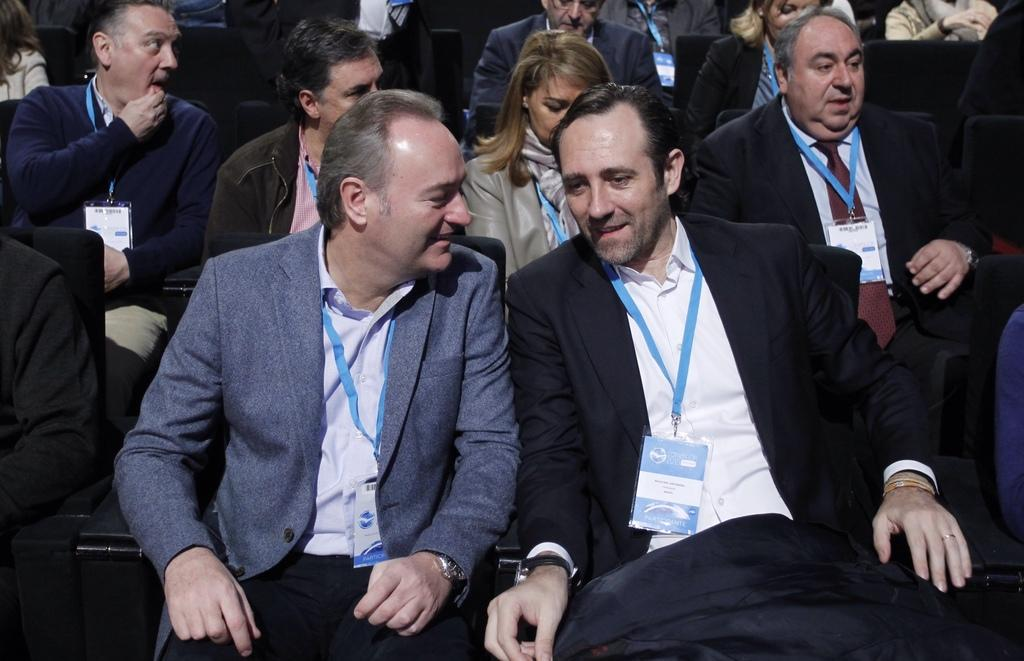What is the main subject of the image? The main subject of the image is a group of people. How can you describe the appearance of the people in the image? The people are wearing different color dresses. What objects are the people holding in the image? The people have identification cards. What are the people doing in the image? The people are sitting on chairs. Can you see any robins in the image? No, there are no robins present in the image. What type of beds are the people lying on in the image? There are no beds in the image; the people are sitting on chairs. 